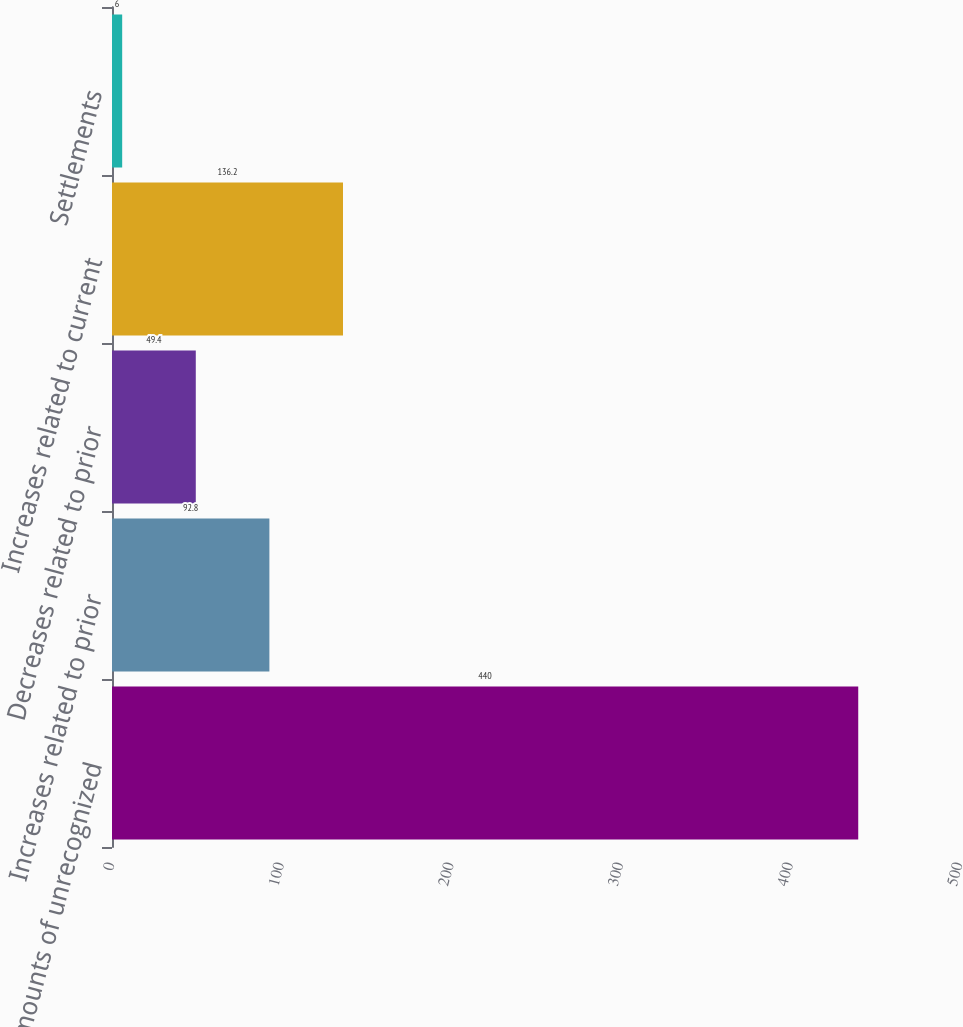Convert chart. <chart><loc_0><loc_0><loc_500><loc_500><bar_chart><fcel>Gross amounts of unrecognized<fcel>Increases related to prior<fcel>Decreases related to prior<fcel>Increases related to current<fcel>Settlements<nl><fcel>440<fcel>92.8<fcel>49.4<fcel>136.2<fcel>6<nl></chart> 